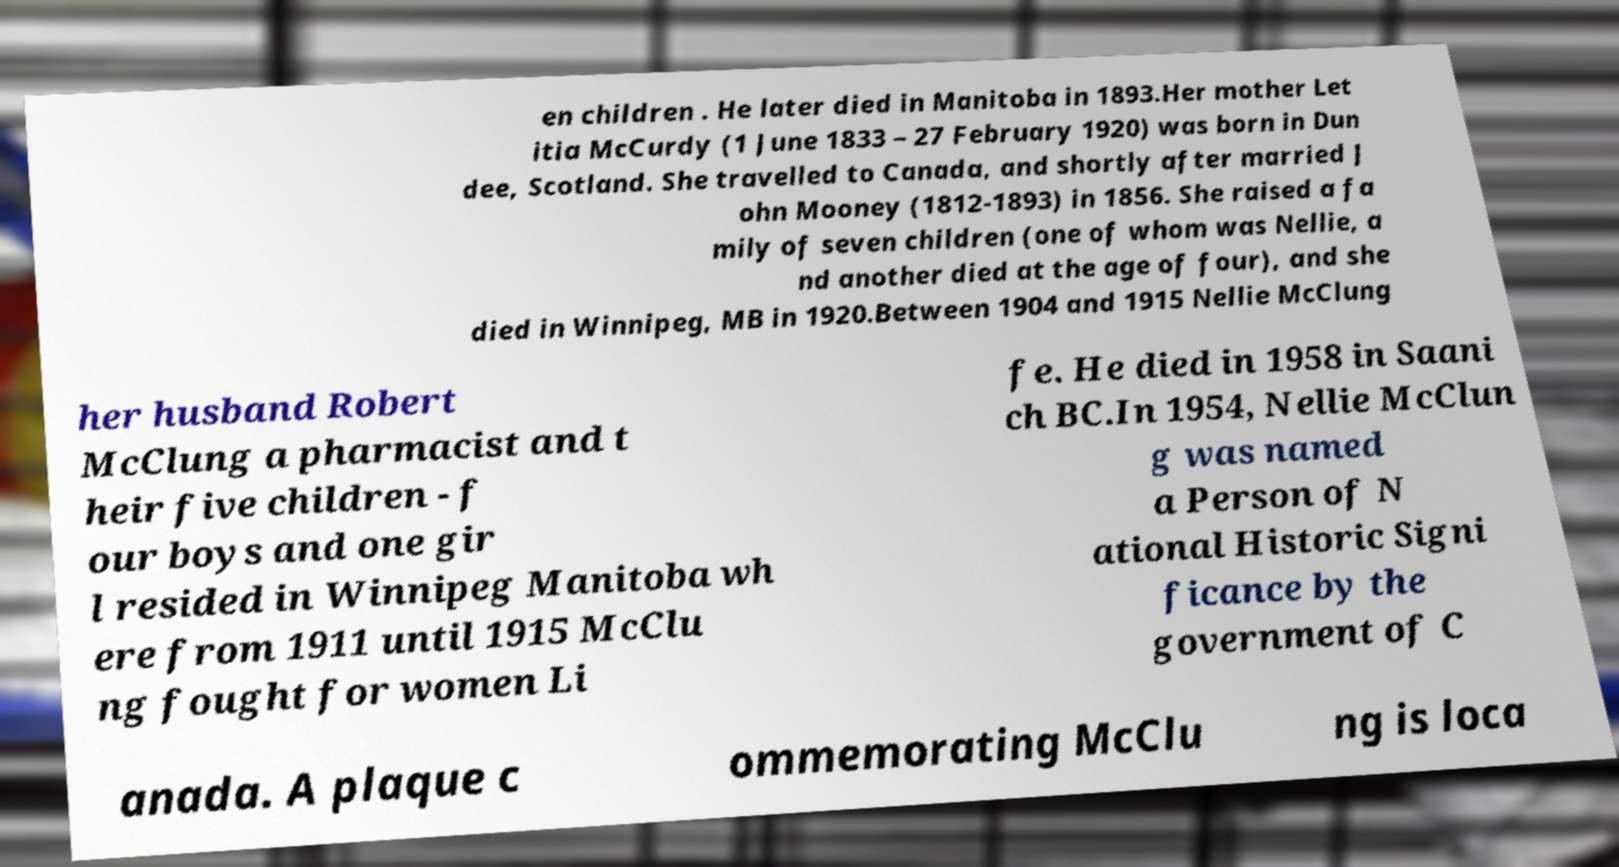What messages or text are displayed in this image? I need them in a readable, typed format. en children . He later died in Manitoba in 1893.Her mother Let itia McCurdy (1 June 1833 – 27 February 1920) was born in Dun dee, Scotland. She travelled to Canada, and shortly after married J ohn Mooney (1812-1893) in 1856. She raised a fa mily of seven children (one of whom was Nellie, a nd another died at the age of four), and she died in Winnipeg, MB in 1920.Between 1904 and 1915 Nellie McClung her husband Robert McClung a pharmacist and t heir five children - f our boys and one gir l resided in Winnipeg Manitoba wh ere from 1911 until 1915 McClu ng fought for women Li fe. He died in 1958 in Saani ch BC.In 1954, Nellie McClun g was named a Person of N ational Historic Signi ficance by the government of C anada. A plaque c ommemorating McClu ng is loca 